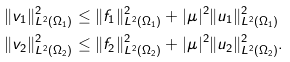<formula> <loc_0><loc_0><loc_500><loc_500>& \| v _ { 1 } \| _ { L ^ { 2 } ( \Omega _ { 1 } ) } ^ { 2 } \leq \| f _ { 1 } \| _ { L ^ { 2 } ( \Omega _ { 1 } ) } ^ { 2 } + | \mu | ^ { 2 } \| u _ { 1 } \| _ { L ^ { 2 } ( \Omega _ { 1 } ) } ^ { 2 } \\ & \| v _ { 2 } \| _ { L ^ { 2 } ( \Omega _ { 2 } ) } ^ { 2 } \leq \| f _ { 2 } \| _ { L ^ { 2 } ( \Omega _ { 2 } ) } ^ { 2 } + | \mu | ^ { 2 } \| u _ { 2 } \| _ { L ^ { 2 } ( \Omega _ { 2 } ) } ^ { 2 } .</formula> 